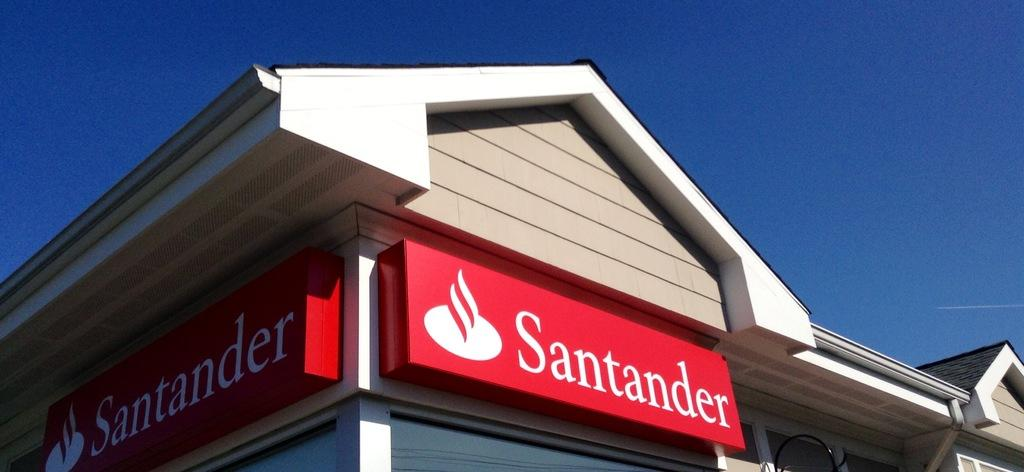What type of structure is visible in the image? There is a house in the image. What other object can be seen in the image? There is a board in the image. What is the color of the board? The board is in red color. What is written on the board? The board has the word "santander" written on it. What is visible at the top of the image? The sky is visible at the top of the image, and it is clear. Is there a shop selling farming equipment in the image? There is no shop or farming equipment present in the image. Is a plough being used in the image? There is no plough visible in the image. 